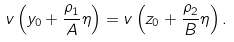<formula> <loc_0><loc_0><loc_500><loc_500>v \left ( y _ { 0 } + \frac { \rho _ { 1 } } { A } \eta \right ) = v \left ( z _ { 0 } + \frac { \rho _ { 2 } } { B } \eta \right ) .</formula> 